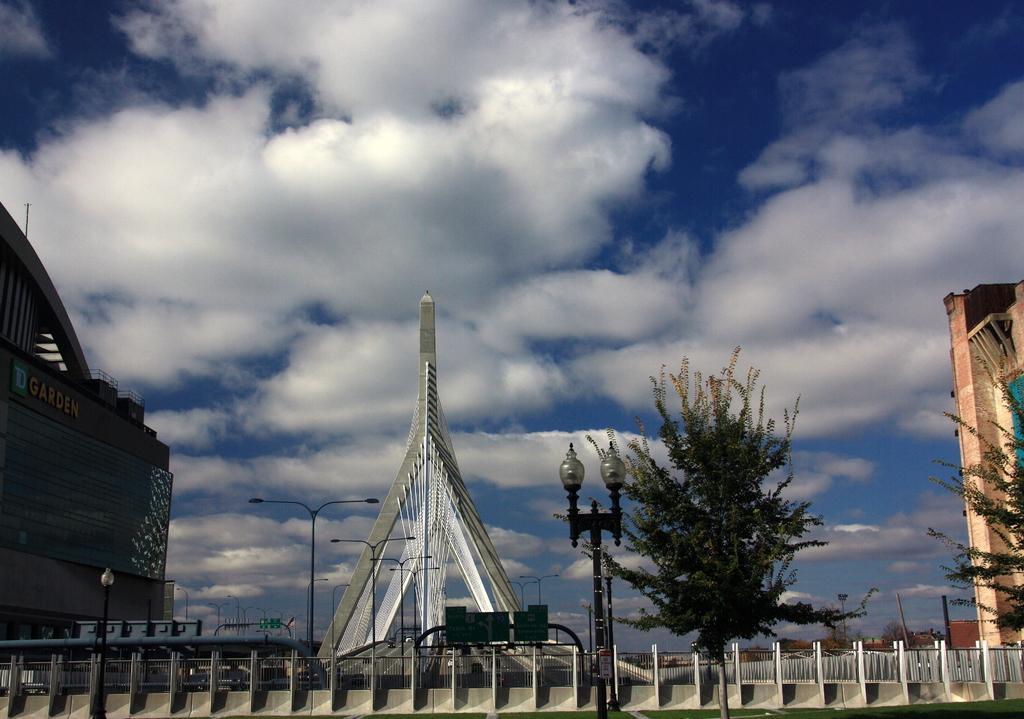Can you describe this image briefly? In this picture there are buildings, trees and poles and there is a tower. In the foreground there is a railing. At the top there is sky and there are clouds. On the right side of the image there is a text on the building. 